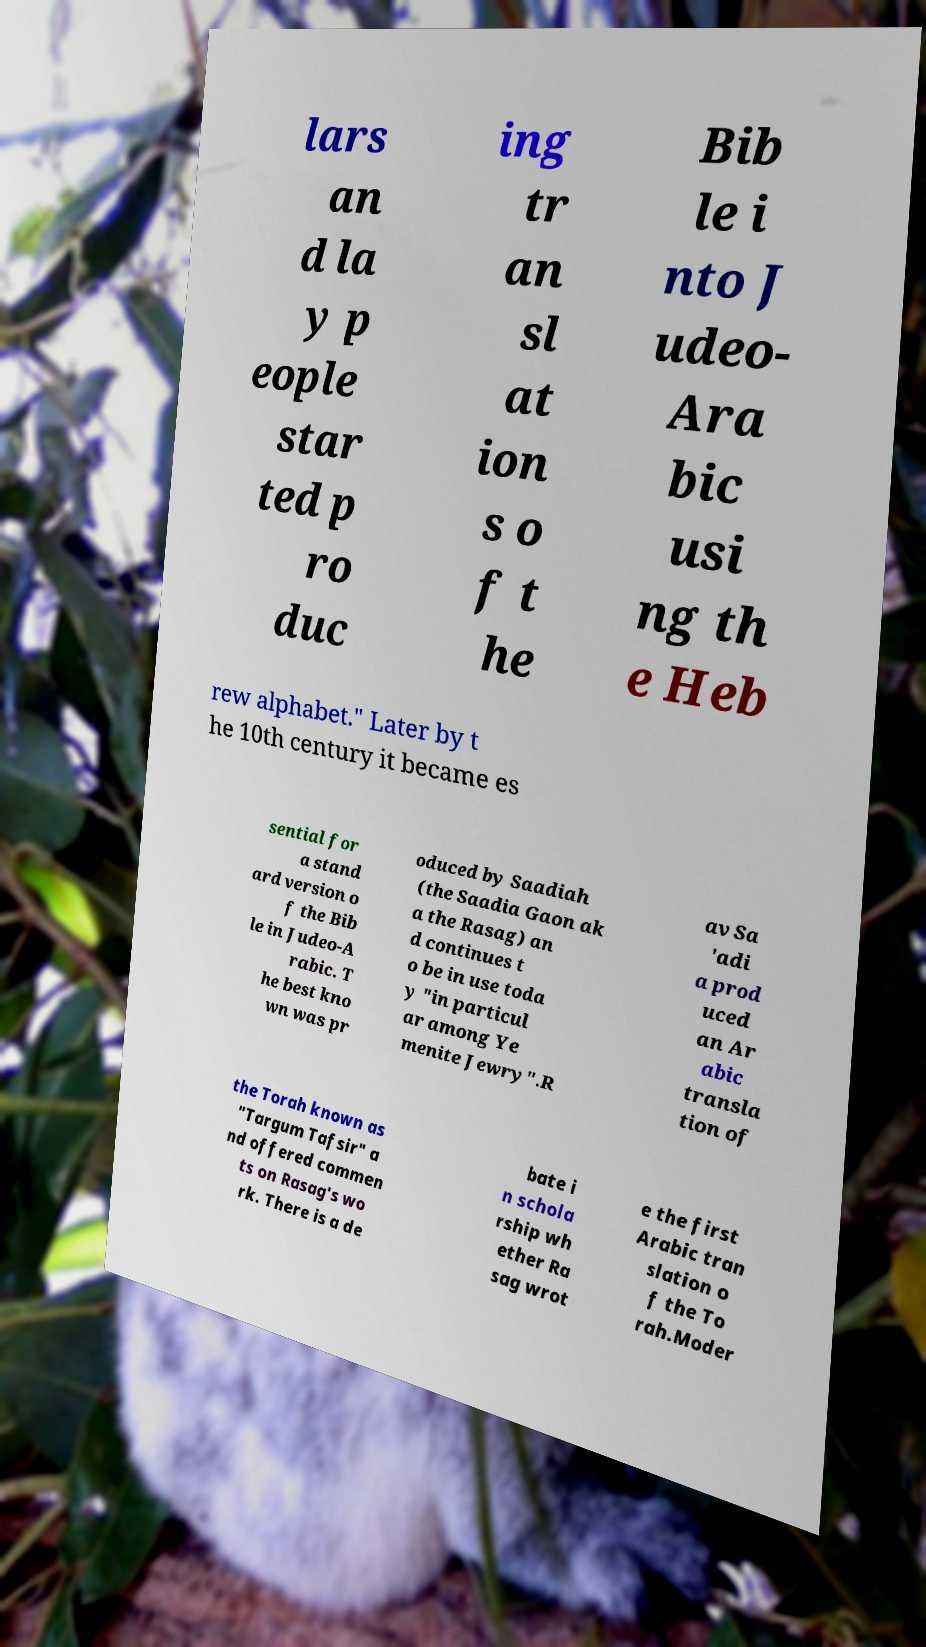I need the written content from this picture converted into text. Can you do that? lars an d la y p eople star ted p ro duc ing tr an sl at ion s o f t he Bib le i nto J udeo- Ara bic usi ng th e Heb rew alphabet." Later by t he 10th century it became es sential for a stand ard version o f the Bib le in Judeo-A rabic. T he best kno wn was pr oduced by Saadiah (the Saadia Gaon ak a the Rasag) an d continues t o be in use toda y "in particul ar among Ye menite Jewry".R av Sa 'adi a prod uced an Ar abic transla tion of the Torah known as "Targum Tafsir" a nd offered commen ts on Rasag's wo rk. There is a de bate i n schola rship wh ether Ra sag wrot e the first Arabic tran slation o f the To rah.Moder 